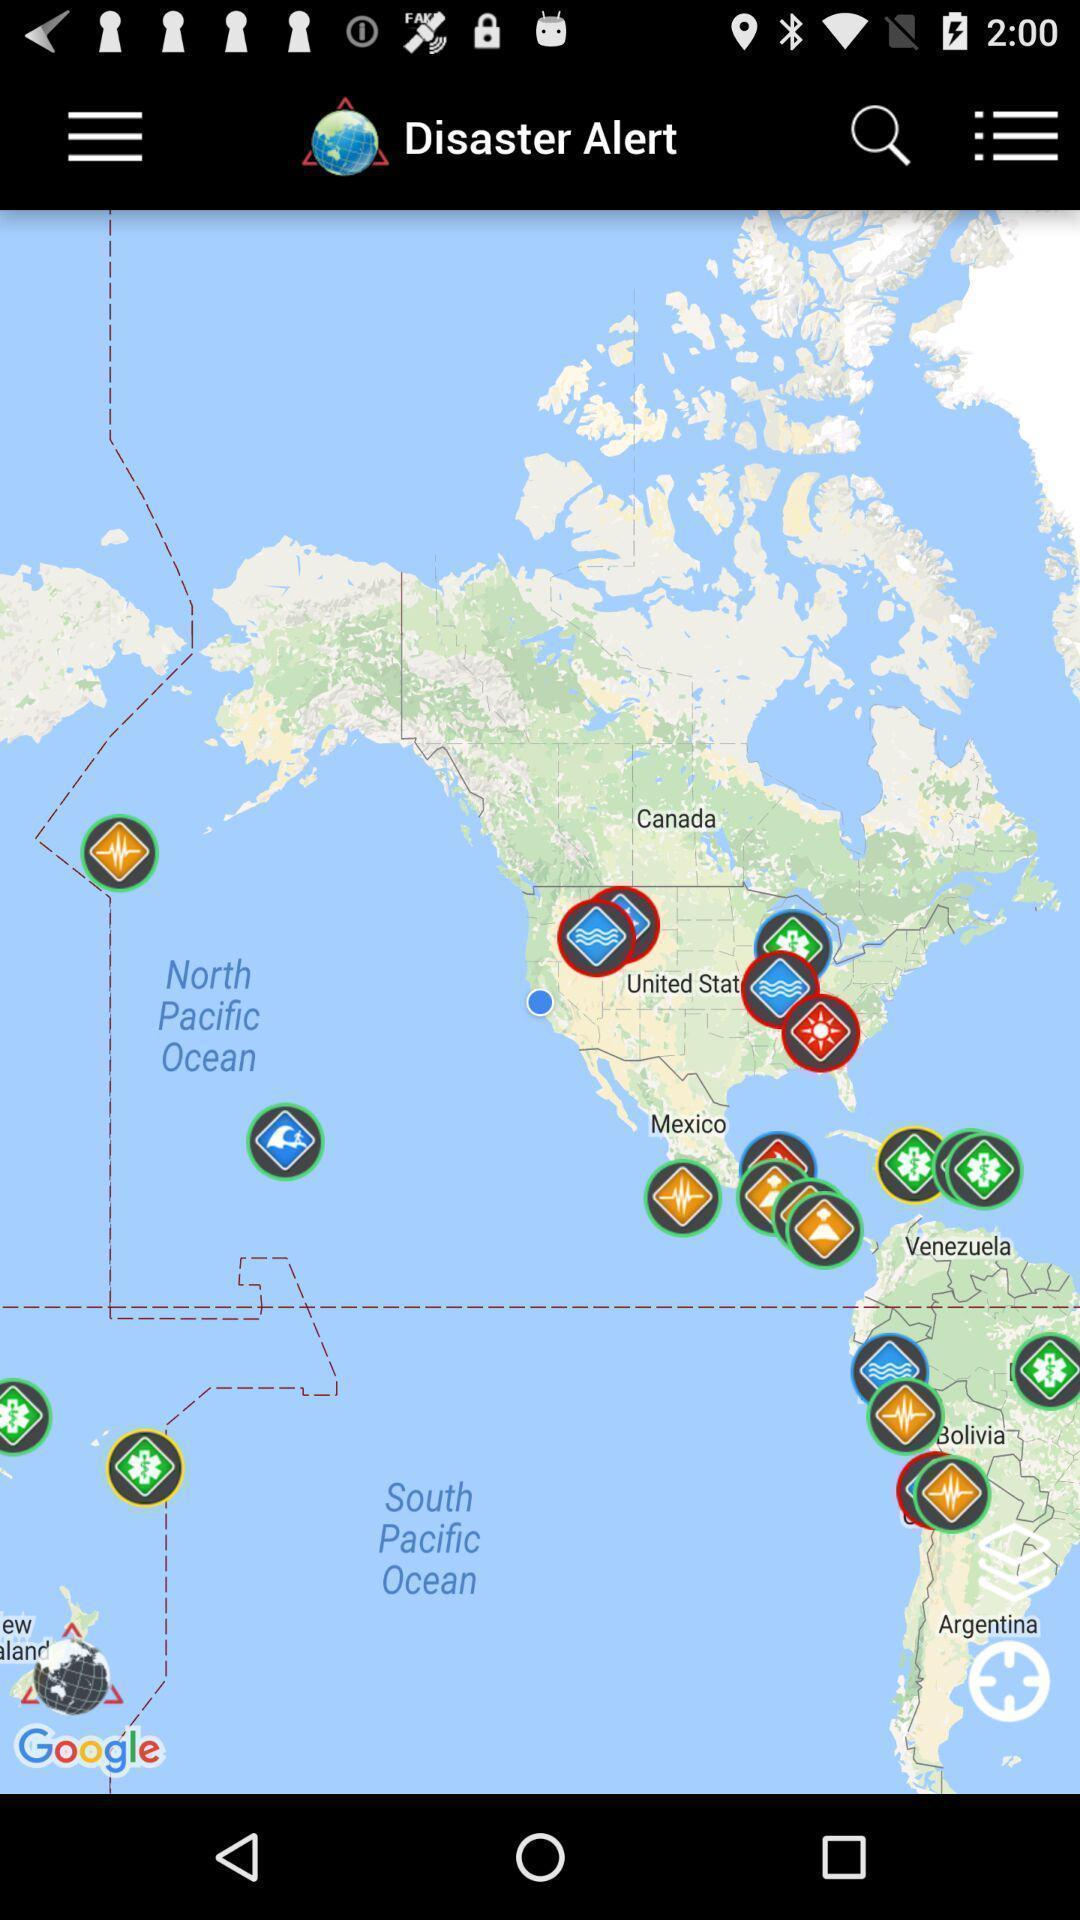Provide a textual representation of this image. Screen shows map view. 